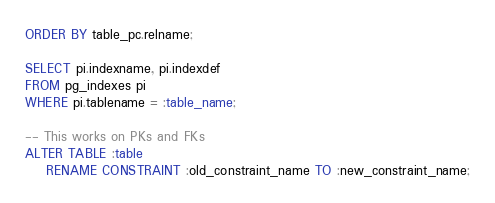<code> <loc_0><loc_0><loc_500><loc_500><_SQL_>ORDER BY table_pc.relname;

SELECT pi.indexname, pi.indexdef
FROM pg_indexes pi
WHERE pi.tablename = :table_name;

-- This works on PKs and FKs
ALTER TABLE :table
    RENAME CONSTRAINT :old_constraint_name TO :new_constraint_name;</code> 